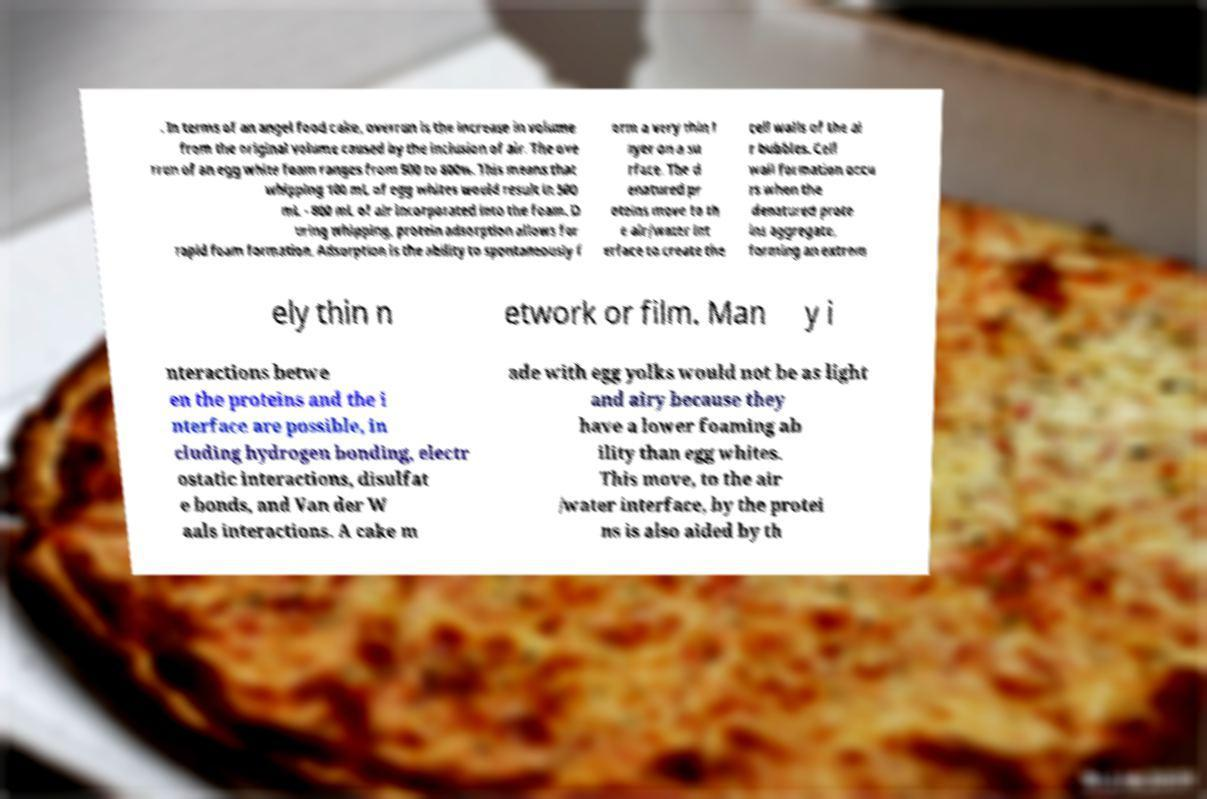Can you read and provide the text displayed in the image?This photo seems to have some interesting text. Can you extract and type it out for me? . In terms of an angel food cake, overrun is the increase in volume from the original volume caused by the inclusion of air. The ove rrun of an egg white foam ranges from 500 to 800%. This means that whipping 100 mL of egg whites would result in 500 mL - 800 mL of air incorporated into the foam. D uring whipping, protein adsorption allows for rapid foam formation. Adsorption is the ability to spontaneously f orm a very thin l ayer on a su rface. The d enatured pr oteins move to th e air/water int erface to create the cell walls of the ai r bubbles. Cell wall formation occu rs when the denatured prote ins aggregate, forming an extrem ely thin n etwork or film. Man y i nteractions betwe en the proteins and the i nterface are possible, in cluding hydrogen bonding, electr ostatic interactions, disulfat e bonds, and Van der W aals interactions. A cake m ade with egg yolks would not be as light and airy because they have a lower foaming ab ility than egg whites. This move, to the air /water interface, by the protei ns is also aided by th 